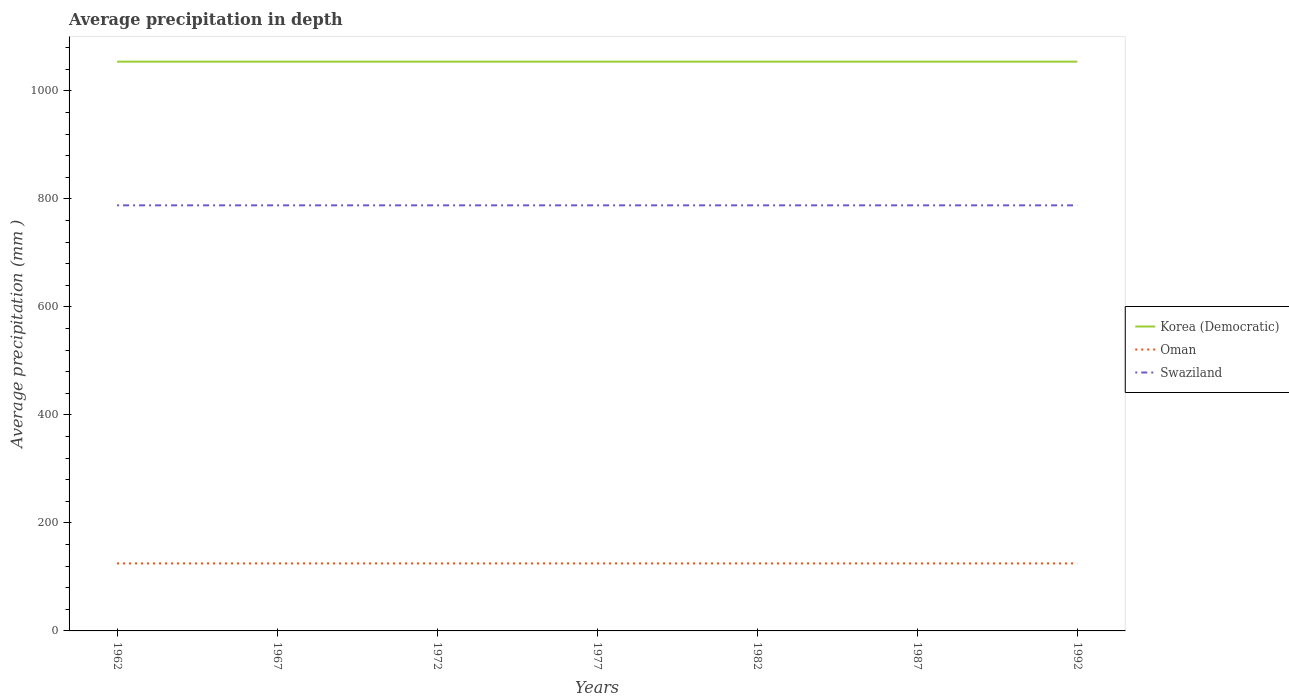Is the number of lines equal to the number of legend labels?
Provide a short and direct response. Yes. Across all years, what is the maximum average precipitation in Oman?
Keep it short and to the point. 125. In which year was the average precipitation in Oman maximum?
Give a very brief answer. 1962. What is the difference between the highest and the second highest average precipitation in Korea (Democratic)?
Provide a short and direct response. 0. How many lines are there?
Provide a short and direct response. 3. How many years are there in the graph?
Offer a terse response. 7. Does the graph contain any zero values?
Offer a very short reply. No. Does the graph contain grids?
Make the answer very short. No. How many legend labels are there?
Your answer should be compact. 3. How are the legend labels stacked?
Provide a succinct answer. Vertical. What is the title of the graph?
Provide a succinct answer. Average precipitation in depth. Does "Guinea" appear as one of the legend labels in the graph?
Make the answer very short. No. What is the label or title of the X-axis?
Offer a very short reply. Years. What is the label or title of the Y-axis?
Offer a very short reply. Average precipitation (mm ). What is the Average precipitation (mm ) in Korea (Democratic) in 1962?
Provide a succinct answer. 1054. What is the Average precipitation (mm ) in Oman in 1962?
Ensure brevity in your answer.  125. What is the Average precipitation (mm ) in Swaziland in 1962?
Your answer should be compact. 788. What is the Average precipitation (mm ) in Korea (Democratic) in 1967?
Your answer should be compact. 1054. What is the Average precipitation (mm ) of Oman in 1967?
Make the answer very short. 125. What is the Average precipitation (mm ) in Swaziland in 1967?
Offer a terse response. 788. What is the Average precipitation (mm ) of Korea (Democratic) in 1972?
Give a very brief answer. 1054. What is the Average precipitation (mm ) in Oman in 1972?
Your response must be concise. 125. What is the Average precipitation (mm ) of Swaziland in 1972?
Keep it short and to the point. 788. What is the Average precipitation (mm ) in Korea (Democratic) in 1977?
Ensure brevity in your answer.  1054. What is the Average precipitation (mm ) in Oman in 1977?
Offer a very short reply. 125. What is the Average precipitation (mm ) of Swaziland in 1977?
Ensure brevity in your answer.  788. What is the Average precipitation (mm ) of Korea (Democratic) in 1982?
Provide a short and direct response. 1054. What is the Average precipitation (mm ) in Oman in 1982?
Keep it short and to the point. 125. What is the Average precipitation (mm ) in Swaziland in 1982?
Make the answer very short. 788. What is the Average precipitation (mm ) in Korea (Democratic) in 1987?
Provide a succinct answer. 1054. What is the Average precipitation (mm ) in Oman in 1987?
Provide a short and direct response. 125. What is the Average precipitation (mm ) in Swaziland in 1987?
Make the answer very short. 788. What is the Average precipitation (mm ) in Korea (Democratic) in 1992?
Provide a short and direct response. 1054. What is the Average precipitation (mm ) in Oman in 1992?
Make the answer very short. 125. What is the Average precipitation (mm ) in Swaziland in 1992?
Give a very brief answer. 788. Across all years, what is the maximum Average precipitation (mm ) of Korea (Democratic)?
Your answer should be very brief. 1054. Across all years, what is the maximum Average precipitation (mm ) in Oman?
Offer a terse response. 125. Across all years, what is the maximum Average precipitation (mm ) of Swaziland?
Keep it short and to the point. 788. Across all years, what is the minimum Average precipitation (mm ) of Korea (Democratic)?
Keep it short and to the point. 1054. Across all years, what is the minimum Average precipitation (mm ) in Oman?
Ensure brevity in your answer.  125. Across all years, what is the minimum Average precipitation (mm ) in Swaziland?
Your answer should be compact. 788. What is the total Average precipitation (mm ) of Korea (Democratic) in the graph?
Make the answer very short. 7378. What is the total Average precipitation (mm ) of Oman in the graph?
Keep it short and to the point. 875. What is the total Average precipitation (mm ) of Swaziland in the graph?
Make the answer very short. 5516. What is the difference between the Average precipitation (mm ) in Korea (Democratic) in 1962 and that in 1967?
Keep it short and to the point. 0. What is the difference between the Average precipitation (mm ) of Oman in 1962 and that in 1967?
Provide a succinct answer. 0. What is the difference between the Average precipitation (mm ) of Korea (Democratic) in 1962 and that in 1972?
Make the answer very short. 0. What is the difference between the Average precipitation (mm ) in Korea (Democratic) in 1962 and that in 1982?
Your response must be concise. 0. What is the difference between the Average precipitation (mm ) of Swaziland in 1962 and that in 1982?
Make the answer very short. 0. What is the difference between the Average precipitation (mm ) in Korea (Democratic) in 1962 and that in 1987?
Offer a very short reply. 0. What is the difference between the Average precipitation (mm ) of Korea (Democratic) in 1962 and that in 1992?
Ensure brevity in your answer.  0. What is the difference between the Average precipitation (mm ) in Oman in 1962 and that in 1992?
Keep it short and to the point. 0. What is the difference between the Average precipitation (mm ) in Swaziland in 1962 and that in 1992?
Your answer should be compact. 0. What is the difference between the Average precipitation (mm ) of Korea (Democratic) in 1967 and that in 1972?
Your answer should be compact. 0. What is the difference between the Average precipitation (mm ) in Swaziland in 1967 and that in 1972?
Make the answer very short. 0. What is the difference between the Average precipitation (mm ) of Korea (Democratic) in 1967 and that in 1977?
Make the answer very short. 0. What is the difference between the Average precipitation (mm ) of Swaziland in 1967 and that in 1977?
Offer a terse response. 0. What is the difference between the Average precipitation (mm ) in Oman in 1967 and that in 1982?
Make the answer very short. 0. What is the difference between the Average precipitation (mm ) of Swaziland in 1967 and that in 1982?
Give a very brief answer. 0. What is the difference between the Average precipitation (mm ) of Korea (Democratic) in 1967 and that in 1987?
Your answer should be very brief. 0. What is the difference between the Average precipitation (mm ) in Swaziland in 1967 and that in 1987?
Make the answer very short. 0. What is the difference between the Average precipitation (mm ) in Swaziland in 1967 and that in 1992?
Your response must be concise. 0. What is the difference between the Average precipitation (mm ) of Oman in 1972 and that in 1977?
Your answer should be very brief. 0. What is the difference between the Average precipitation (mm ) in Oman in 1972 and that in 1982?
Your answer should be compact. 0. What is the difference between the Average precipitation (mm ) in Oman in 1972 and that in 1987?
Provide a short and direct response. 0. What is the difference between the Average precipitation (mm ) in Korea (Democratic) in 1972 and that in 1992?
Your answer should be very brief. 0. What is the difference between the Average precipitation (mm ) in Oman in 1972 and that in 1992?
Keep it short and to the point. 0. What is the difference between the Average precipitation (mm ) in Swaziland in 1972 and that in 1992?
Offer a terse response. 0. What is the difference between the Average precipitation (mm ) in Korea (Democratic) in 1977 and that in 1982?
Keep it short and to the point. 0. What is the difference between the Average precipitation (mm ) in Korea (Democratic) in 1977 and that in 1987?
Your answer should be compact. 0. What is the difference between the Average precipitation (mm ) of Oman in 1977 and that in 1987?
Provide a succinct answer. 0. What is the difference between the Average precipitation (mm ) in Swaziland in 1977 and that in 1987?
Your answer should be compact. 0. What is the difference between the Average precipitation (mm ) in Oman in 1977 and that in 1992?
Give a very brief answer. 0. What is the difference between the Average precipitation (mm ) in Korea (Democratic) in 1982 and that in 1987?
Your answer should be compact. 0. What is the difference between the Average precipitation (mm ) of Oman in 1987 and that in 1992?
Make the answer very short. 0. What is the difference between the Average precipitation (mm ) in Korea (Democratic) in 1962 and the Average precipitation (mm ) in Oman in 1967?
Offer a very short reply. 929. What is the difference between the Average precipitation (mm ) of Korea (Democratic) in 1962 and the Average precipitation (mm ) of Swaziland in 1967?
Keep it short and to the point. 266. What is the difference between the Average precipitation (mm ) of Oman in 1962 and the Average precipitation (mm ) of Swaziland in 1967?
Make the answer very short. -663. What is the difference between the Average precipitation (mm ) of Korea (Democratic) in 1962 and the Average precipitation (mm ) of Oman in 1972?
Provide a short and direct response. 929. What is the difference between the Average precipitation (mm ) in Korea (Democratic) in 1962 and the Average precipitation (mm ) in Swaziland in 1972?
Your answer should be compact. 266. What is the difference between the Average precipitation (mm ) in Oman in 1962 and the Average precipitation (mm ) in Swaziland in 1972?
Give a very brief answer. -663. What is the difference between the Average precipitation (mm ) in Korea (Democratic) in 1962 and the Average precipitation (mm ) in Oman in 1977?
Make the answer very short. 929. What is the difference between the Average precipitation (mm ) of Korea (Democratic) in 1962 and the Average precipitation (mm ) of Swaziland in 1977?
Provide a short and direct response. 266. What is the difference between the Average precipitation (mm ) in Oman in 1962 and the Average precipitation (mm ) in Swaziland in 1977?
Keep it short and to the point. -663. What is the difference between the Average precipitation (mm ) of Korea (Democratic) in 1962 and the Average precipitation (mm ) of Oman in 1982?
Keep it short and to the point. 929. What is the difference between the Average precipitation (mm ) in Korea (Democratic) in 1962 and the Average precipitation (mm ) in Swaziland in 1982?
Keep it short and to the point. 266. What is the difference between the Average precipitation (mm ) of Oman in 1962 and the Average precipitation (mm ) of Swaziland in 1982?
Your response must be concise. -663. What is the difference between the Average precipitation (mm ) of Korea (Democratic) in 1962 and the Average precipitation (mm ) of Oman in 1987?
Ensure brevity in your answer.  929. What is the difference between the Average precipitation (mm ) in Korea (Democratic) in 1962 and the Average precipitation (mm ) in Swaziland in 1987?
Your answer should be compact. 266. What is the difference between the Average precipitation (mm ) of Oman in 1962 and the Average precipitation (mm ) of Swaziland in 1987?
Ensure brevity in your answer.  -663. What is the difference between the Average precipitation (mm ) of Korea (Democratic) in 1962 and the Average precipitation (mm ) of Oman in 1992?
Keep it short and to the point. 929. What is the difference between the Average precipitation (mm ) in Korea (Democratic) in 1962 and the Average precipitation (mm ) in Swaziland in 1992?
Your answer should be compact. 266. What is the difference between the Average precipitation (mm ) in Oman in 1962 and the Average precipitation (mm ) in Swaziland in 1992?
Ensure brevity in your answer.  -663. What is the difference between the Average precipitation (mm ) of Korea (Democratic) in 1967 and the Average precipitation (mm ) of Oman in 1972?
Provide a succinct answer. 929. What is the difference between the Average precipitation (mm ) in Korea (Democratic) in 1967 and the Average precipitation (mm ) in Swaziland in 1972?
Provide a succinct answer. 266. What is the difference between the Average precipitation (mm ) of Oman in 1967 and the Average precipitation (mm ) of Swaziland in 1972?
Provide a succinct answer. -663. What is the difference between the Average precipitation (mm ) of Korea (Democratic) in 1967 and the Average precipitation (mm ) of Oman in 1977?
Keep it short and to the point. 929. What is the difference between the Average precipitation (mm ) in Korea (Democratic) in 1967 and the Average precipitation (mm ) in Swaziland in 1977?
Your answer should be very brief. 266. What is the difference between the Average precipitation (mm ) of Oman in 1967 and the Average precipitation (mm ) of Swaziland in 1977?
Your response must be concise. -663. What is the difference between the Average precipitation (mm ) in Korea (Democratic) in 1967 and the Average precipitation (mm ) in Oman in 1982?
Ensure brevity in your answer.  929. What is the difference between the Average precipitation (mm ) in Korea (Democratic) in 1967 and the Average precipitation (mm ) in Swaziland in 1982?
Your answer should be very brief. 266. What is the difference between the Average precipitation (mm ) of Oman in 1967 and the Average precipitation (mm ) of Swaziland in 1982?
Provide a succinct answer. -663. What is the difference between the Average precipitation (mm ) of Korea (Democratic) in 1967 and the Average precipitation (mm ) of Oman in 1987?
Your answer should be very brief. 929. What is the difference between the Average precipitation (mm ) of Korea (Democratic) in 1967 and the Average precipitation (mm ) of Swaziland in 1987?
Your response must be concise. 266. What is the difference between the Average precipitation (mm ) of Oman in 1967 and the Average precipitation (mm ) of Swaziland in 1987?
Offer a terse response. -663. What is the difference between the Average precipitation (mm ) of Korea (Democratic) in 1967 and the Average precipitation (mm ) of Oman in 1992?
Your answer should be compact. 929. What is the difference between the Average precipitation (mm ) of Korea (Democratic) in 1967 and the Average precipitation (mm ) of Swaziland in 1992?
Provide a short and direct response. 266. What is the difference between the Average precipitation (mm ) of Oman in 1967 and the Average precipitation (mm ) of Swaziland in 1992?
Make the answer very short. -663. What is the difference between the Average precipitation (mm ) in Korea (Democratic) in 1972 and the Average precipitation (mm ) in Oman in 1977?
Provide a short and direct response. 929. What is the difference between the Average precipitation (mm ) in Korea (Democratic) in 1972 and the Average precipitation (mm ) in Swaziland in 1977?
Make the answer very short. 266. What is the difference between the Average precipitation (mm ) in Oman in 1972 and the Average precipitation (mm ) in Swaziland in 1977?
Your response must be concise. -663. What is the difference between the Average precipitation (mm ) of Korea (Democratic) in 1972 and the Average precipitation (mm ) of Oman in 1982?
Offer a very short reply. 929. What is the difference between the Average precipitation (mm ) of Korea (Democratic) in 1972 and the Average precipitation (mm ) of Swaziland in 1982?
Your answer should be compact. 266. What is the difference between the Average precipitation (mm ) in Oman in 1972 and the Average precipitation (mm ) in Swaziland in 1982?
Your answer should be compact. -663. What is the difference between the Average precipitation (mm ) in Korea (Democratic) in 1972 and the Average precipitation (mm ) in Oman in 1987?
Your response must be concise. 929. What is the difference between the Average precipitation (mm ) in Korea (Democratic) in 1972 and the Average precipitation (mm ) in Swaziland in 1987?
Provide a short and direct response. 266. What is the difference between the Average precipitation (mm ) in Oman in 1972 and the Average precipitation (mm ) in Swaziland in 1987?
Your response must be concise. -663. What is the difference between the Average precipitation (mm ) of Korea (Democratic) in 1972 and the Average precipitation (mm ) of Oman in 1992?
Ensure brevity in your answer.  929. What is the difference between the Average precipitation (mm ) of Korea (Democratic) in 1972 and the Average precipitation (mm ) of Swaziland in 1992?
Ensure brevity in your answer.  266. What is the difference between the Average precipitation (mm ) of Oman in 1972 and the Average precipitation (mm ) of Swaziland in 1992?
Give a very brief answer. -663. What is the difference between the Average precipitation (mm ) of Korea (Democratic) in 1977 and the Average precipitation (mm ) of Oman in 1982?
Offer a very short reply. 929. What is the difference between the Average precipitation (mm ) in Korea (Democratic) in 1977 and the Average precipitation (mm ) in Swaziland in 1982?
Provide a succinct answer. 266. What is the difference between the Average precipitation (mm ) of Oman in 1977 and the Average precipitation (mm ) of Swaziland in 1982?
Ensure brevity in your answer.  -663. What is the difference between the Average precipitation (mm ) of Korea (Democratic) in 1977 and the Average precipitation (mm ) of Oman in 1987?
Provide a succinct answer. 929. What is the difference between the Average precipitation (mm ) of Korea (Democratic) in 1977 and the Average precipitation (mm ) of Swaziland in 1987?
Provide a succinct answer. 266. What is the difference between the Average precipitation (mm ) in Oman in 1977 and the Average precipitation (mm ) in Swaziland in 1987?
Offer a terse response. -663. What is the difference between the Average precipitation (mm ) of Korea (Democratic) in 1977 and the Average precipitation (mm ) of Oman in 1992?
Provide a short and direct response. 929. What is the difference between the Average precipitation (mm ) of Korea (Democratic) in 1977 and the Average precipitation (mm ) of Swaziland in 1992?
Make the answer very short. 266. What is the difference between the Average precipitation (mm ) in Oman in 1977 and the Average precipitation (mm ) in Swaziland in 1992?
Make the answer very short. -663. What is the difference between the Average precipitation (mm ) of Korea (Democratic) in 1982 and the Average precipitation (mm ) of Oman in 1987?
Provide a succinct answer. 929. What is the difference between the Average precipitation (mm ) in Korea (Democratic) in 1982 and the Average precipitation (mm ) in Swaziland in 1987?
Provide a succinct answer. 266. What is the difference between the Average precipitation (mm ) in Oman in 1982 and the Average precipitation (mm ) in Swaziland in 1987?
Offer a terse response. -663. What is the difference between the Average precipitation (mm ) in Korea (Democratic) in 1982 and the Average precipitation (mm ) in Oman in 1992?
Your answer should be very brief. 929. What is the difference between the Average precipitation (mm ) in Korea (Democratic) in 1982 and the Average precipitation (mm ) in Swaziland in 1992?
Give a very brief answer. 266. What is the difference between the Average precipitation (mm ) of Oman in 1982 and the Average precipitation (mm ) of Swaziland in 1992?
Ensure brevity in your answer.  -663. What is the difference between the Average precipitation (mm ) in Korea (Democratic) in 1987 and the Average precipitation (mm ) in Oman in 1992?
Your answer should be very brief. 929. What is the difference between the Average precipitation (mm ) of Korea (Democratic) in 1987 and the Average precipitation (mm ) of Swaziland in 1992?
Give a very brief answer. 266. What is the difference between the Average precipitation (mm ) of Oman in 1987 and the Average precipitation (mm ) of Swaziland in 1992?
Your answer should be very brief. -663. What is the average Average precipitation (mm ) in Korea (Democratic) per year?
Your answer should be very brief. 1054. What is the average Average precipitation (mm ) in Oman per year?
Provide a succinct answer. 125. What is the average Average precipitation (mm ) in Swaziland per year?
Give a very brief answer. 788. In the year 1962, what is the difference between the Average precipitation (mm ) in Korea (Democratic) and Average precipitation (mm ) in Oman?
Your answer should be compact. 929. In the year 1962, what is the difference between the Average precipitation (mm ) in Korea (Democratic) and Average precipitation (mm ) in Swaziland?
Make the answer very short. 266. In the year 1962, what is the difference between the Average precipitation (mm ) of Oman and Average precipitation (mm ) of Swaziland?
Make the answer very short. -663. In the year 1967, what is the difference between the Average precipitation (mm ) of Korea (Democratic) and Average precipitation (mm ) of Oman?
Your answer should be very brief. 929. In the year 1967, what is the difference between the Average precipitation (mm ) in Korea (Democratic) and Average precipitation (mm ) in Swaziland?
Your answer should be compact. 266. In the year 1967, what is the difference between the Average precipitation (mm ) of Oman and Average precipitation (mm ) of Swaziland?
Provide a short and direct response. -663. In the year 1972, what is the difference between the Average precipitation (mm ) in Korea (Democratic) and Average precipitation (mm ) in Oman?
Keep it short and to the point. 929. In the year 1972, what is the difference between the Average precipitation (mm ) in Korea (Democratic) and Average precipitation (mm ) in Swaziland?
Your answer should be compact. 266. In the year 1972, what is the difference between the Average precipitation (mm ) in Oman and Average precipitation (mm ) in Swaziland?
Give a very brief answer. -663. In the year 1977, what is the difference between the Average precipitation (mm ) of Korea (Democratic) and Average precipitation (mm ) of Oman?
Your response must be concise. 929. In the year 1977, what is the difference between the Average precipitation (mm ) of Korea (Democratic) and Average precipitation (mm ) of Swaziland?
Provide a succinct answer. 266. In the year 1977, what is the difference between the Average precipitation (mm ) of Oman and Average precipitation (mm ) of Swaziland?
Offer a terse response. -663. In the year 1982, what is the difference between the Average precipitation (mm ) in Korea (Democratic) and Average precipitation (mm ) in Oman?
Make the answer very short. 929. In the year 1982, what is the difference between the Average precipitation (mm ) of Korea (Democratic) and Average precipitation (mm ) of Swaziland?
Ensure brevity in your answer.  266. In the year 1982, what is the difference between the Average precipitation (mm ) in Oman and Average precipitation (mm ) in Swaziland?
Give a very brief answer. -663. In the year 1987, what is the difference between the Average precipitation (mm ) in Korea (Democratic) and Average precipitation (mm ) in Oman?
Offer a terse response. 929. In the year 1987, what is the difference between the Average precipitation (mm ) in Korea (Democratic) and Average precipitation (mm ) in Swaziland?
Provide a succinct answer. 266. In the year 1987, what is the difference between the Average precipitation (mm ) in Oman and Average precipitation (mm ) in Swaziland?
Your answer should be compact. -663. In the year 1992, what is the difference between the Average precipitation (mm ) in Korea (Democratic) and Average precipitation (mm ) in Oman?
Keep it short and to the point. 929. In the year 1992, what is the difference between the Average precipitation (mm ) in Korea (Democratic) and Average precipitation (mm ) in Swaziland?
Ensure brevity in your answer.  266. In the year 1992, what is the difference between the Average precipitation (mm ) in Oman and Average precipitation (mm ) in Swaziland?
Give a very brief answer. -663. What is the ratio of the Average precipitation (mm ) of Korea (Democratic) in 1962 to that in 1967?
Give a very brief answer. 1. What is the ratio of the Average precipitation (mm ) of Swaziland in 1962 to that in 1967?
Offer a very short reply. 1. What is the ratio of the Average precipitation (mm ) in Korea (Democratic) in 1962 to that in 1972?
Offer a very short reply. 1. What is the ratio of the Average precipitation (mm ) of Korea (Democratic) in 1962 to that in 1977?
Your response must be concise. 1. What is the ratio of the Average precipitation (mm ) of Swaziland in 1962 to that in 1977?
Your answer should be very brief. 1. What is the ratio of the Average precipitation (mm ) of Korea (Democratic) in 1962 to that in 1982?
Give a very brief answer. 1. What is the ratio of the Average precipitation (mm ) in Oman in 1962 to that in 1982?
Your answer should be compact. 1. What is the ratio of the Average precipitation (mm ) of Swaziland in 1962 to that in 1982?
Offer a terse response. 1. What is the ratio of the Average precipitation (mm ) in Swaziland in 1962 to that in 1987?
Offer a very short reply. 1. What is the ratio of the Average precipitation (mm ) of Korea (Democratic) in 1962 to that in 1992?
Offer a very short reply. 1. What is the ratio of the Average precipitation (mm ) in Oman in 1962 to that in 1992?
Offer a very short reply. 1. What is the ratio of the Average precipitation (mm ) in Korea (Democratic) in 1967 to that in 1972?
Give a very brief answer. 1. What is the ratio of the Average precipitation (mm ) of Oman in 1967 to that in 1972?
Provide a short and direct response. 1. What is the ratio of the Average precipitation (mm ) of Swaziland in 1967 to that in 1972?
Your answer should be compact. 1. What is the ratio of the Average precipitation (mm ) in Korea (Democratic) in 1967 to that in 1977?
Make the answer very short. 1. What is the ratio of the Average precipitation (mm ) in Oman in 1967 to that in 1977?
Offer a very short reply. 1. What is the ratio of the Average precipitation (mm ) in Swaziland in 1967 to that in 1977?
Keep it short and to the point. 1. What is the ratio of the Average precipitation (mm ) of Korea (Democratic) in 1967 to that in 1982?
Your answer should be very brief. 1. What is the ratio of the Average precipitation (mm ) in Swaziland in 1967 to that in 1982?
Provide a succinct answer. 1. What is the ratio of the Average precipitation (mm ) in Swaziland in 1967 to that in 1987?
Your response must be concise. 1. What is the ratio of the Average precipitation (mm ) in Korea (Democratic) in 1967 to that in 1992?
Offer a terse response. 1. What is the ratio of the Average precipitation (mm ) in Swaziland in 1967 to that in 1992?
Give a very brief answer. 1. What is the ratio of the Average precipitation (mm ) of Oman in 1972 to that in 1977?
Make the answer very short. 1. What is the ratio of the Average precipitation (mm ) in Swaziland in 1972 to that in 1977?
Keep it short and to the point. 1. What is the ratio of the Average precipitation (mm ) in Oman in 1972 to that in 1982?
Your answer should be compact. 1. What is the ratio of the Average precipitation (mm ) of Swaziland in 1972 to that in 1982?
Keep it short and to the point. 1. What is the ratio of the Average precipitation (mm ) of Oman in 1972 to that in 1987?
Give a very brief answer. 1. What is the ratio of the Average precipitation (mm ) in Swaziland in 1972 to that in 1987?
Offer a terse response. 1. What is the ratio of the Average precipitation (mm ) in Korea (Democratic) in 1972 to that in 1992?
Make the answer very short. 1. What is the ratio of the Average precipitation (mm ) of Oman in 1972 to that in 1992?
Your answer should be compact. 1. What is the ratio of the Average precipitation (mm ) in Swaziland in 1972 to that in 1992?
Ensure brevity in your answer.  1. What is the ratio of the Average precipitation (mm ) of Swaziland in 1977 to that in 1982?
Offer a very short reply. 1. What is the ratio of the Average precipitation (mm ) in Oman in 1977 to that in 1987?
Your response must be concise. 1. What is the ratio of the Average precipitation (mm ) in Swaziland in 1977 to that in 1987?
Provide a succinct answer. 1. What is the ratio of the Average precipitation (mm ) in Korea (Democratic) in 1977 to that in 1992?
Give a very brief answer. 1. What is the ratio of the Average precipitation (mm ) in Oman in 1977 to that in 1992?
Make the answer very short. 1. What is the ratio of the Average precipitation (mm ) in Swaziland in 1977 to that in 1992?
Your answer should be compact. 1. What is the ratio of the Average precipitation (mm ) in Oman in 1982 to that in 1987?
Make the answer very short. 1. What is the ratio of the Average precipitation (mm ) in Oman in 1982 to that in 1992?
Your answer should be very brief. 1. What is the ratio of the Average precipitation (mm ) of Swaziland in 1982 to that in 1992?
Provide a short and direct response. 1. What is the ratio of the Average precipitation (mm ) in Korea (Democratic) in 1987 to that in 1992?
Offer a very short reply. 1. What is the difference between the highest and the second highest Average precipitation (mm ) in Oman?
Your answer should be very brief. 0. What is the difference between the highest and the lowest Average precipitation (mm ) in Korea (Democratic)?
Make the answer very short. 0. What is the difference between the highest and the lowest Average precipitation (mm ) in Swaziland?
Make the answer very short. 0. 